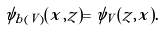Convert formula to latex. <formula><loc_0><loc_0><loc_500><loc_500>\psi _ { b ( V ) } ( x , z ) = \psi _ { V } ( z , x ) .</formula> 